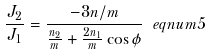<formula> <loc_0><loc_0><loc_500><loc_500>\frac { J _ { 2 } } { J _ { 1 } } = \frac { - 3 n / m } { \frac { n _ { 2 } } m + \frac { 2 n _ { 1 } } m \cos \phi } \ e q n u m { 5 }</formula> 